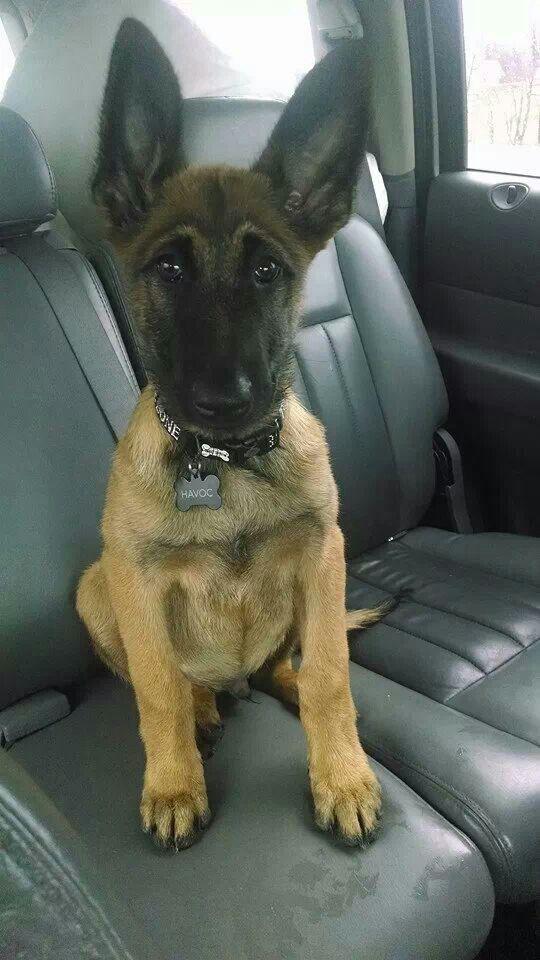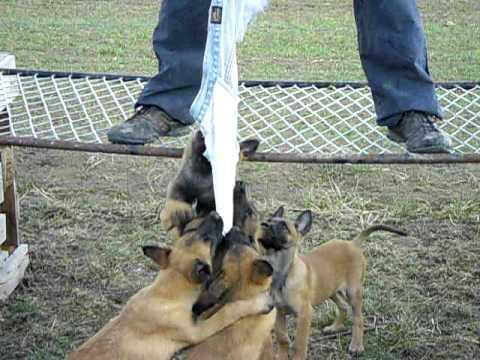The first image is the image on the left, the second image is the image on the right. For the images shown, is this caption "The dog in the image on the left is on a leash." true? Answer yes or no. No. The first image is the image on the left, the second image is the image on the right. For the images displayed, is the sentence "One image shows a standing dog wearing a leash, and the other shows a dog sitting upright." factually correct? Answer yes or no. No. 